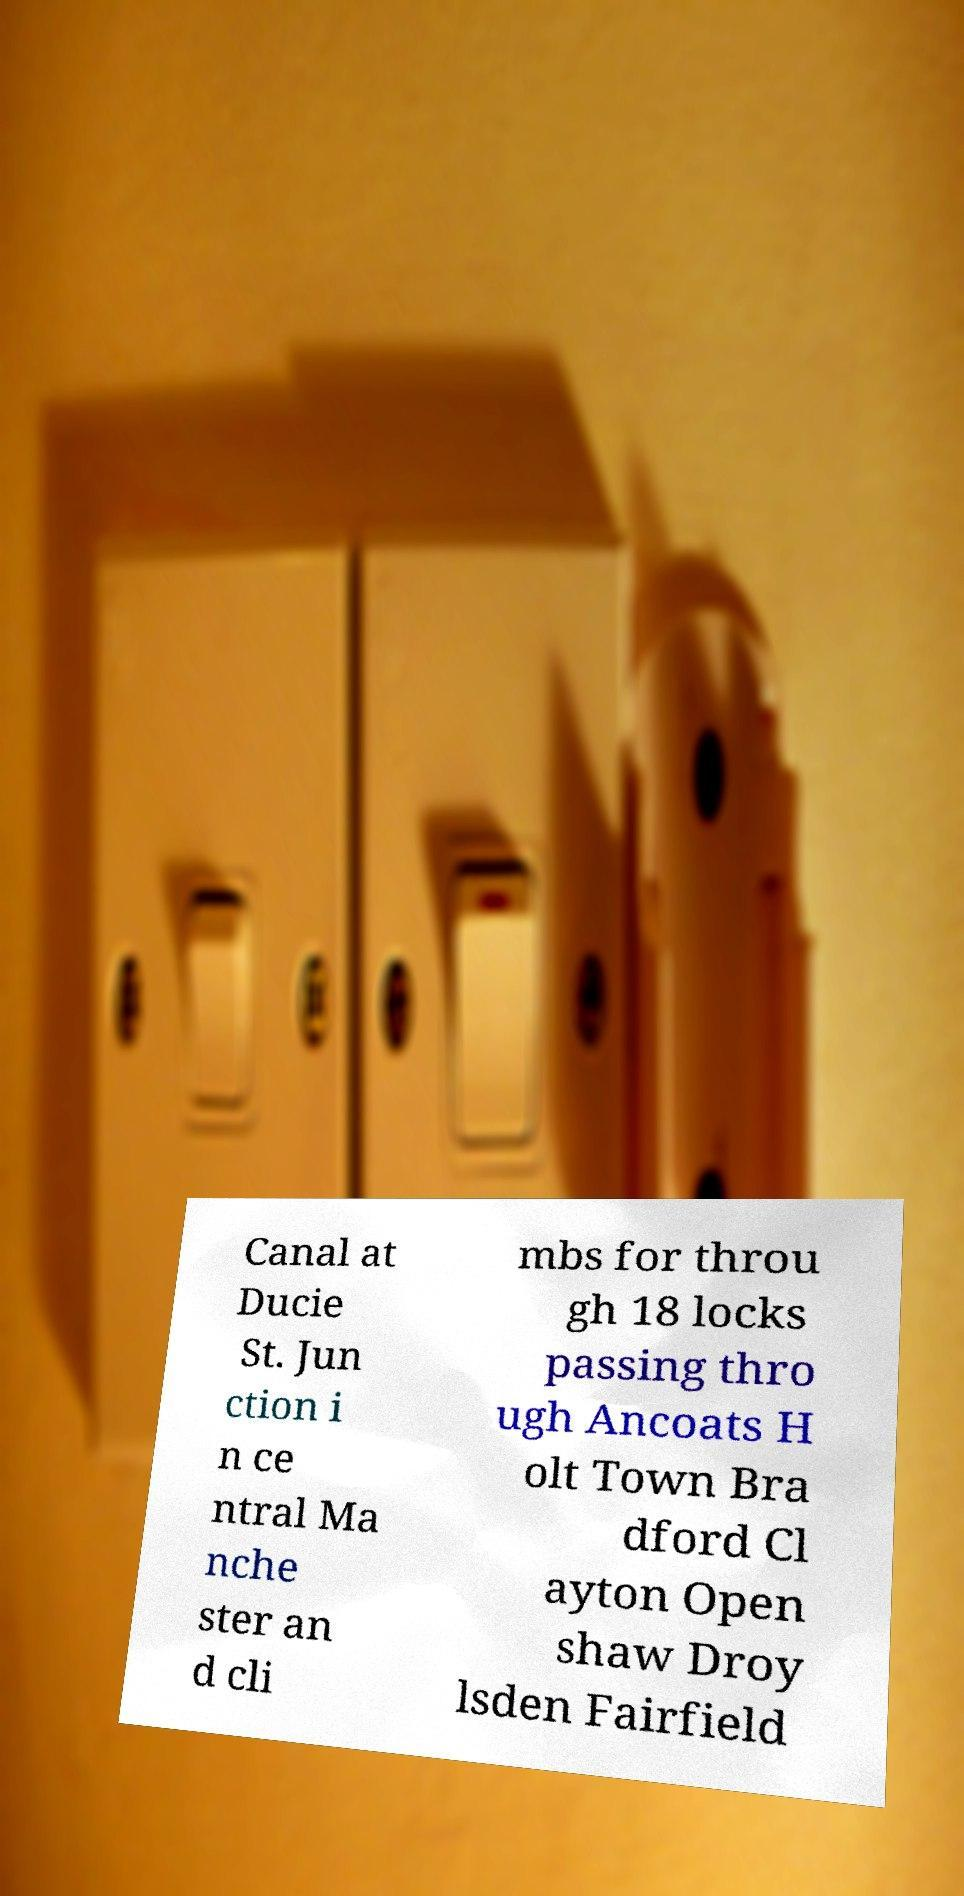Can you read and provide the text displayed in the image?This photo seems to have some interesting text. Can you extract and type it out for me? Canal at Ducie St. Jun ction i n ce ntral Ma nche ster an d cli mbs for throu gh 18 locks passing thro ugh Ancoats H olt Town Bra dford Cl ayton Open shaw Droy lsden Fairfield 